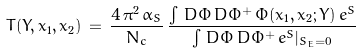Convert formula to latex. <formula><loc_0><loc_0><loc_500><loc_500>T ( Y , x _ { 1 } , x _ { 2 } ) \, = \, \frac { 4 \, \pi ^ { 2 } \, \bar { \alpha } _ { S } } { N _ { c } } \, \frac { \int \, D \Phi \, D \Phi ^ { + } \, \Phi ( x _ { 1 } , x _ { 2 } ; Y ) \, e ^ { S } } { \int \, D \Phi \, D \Phi ^ { + } \, e ^ { S } | _ { S _ { E } = 0 } }</formula> 